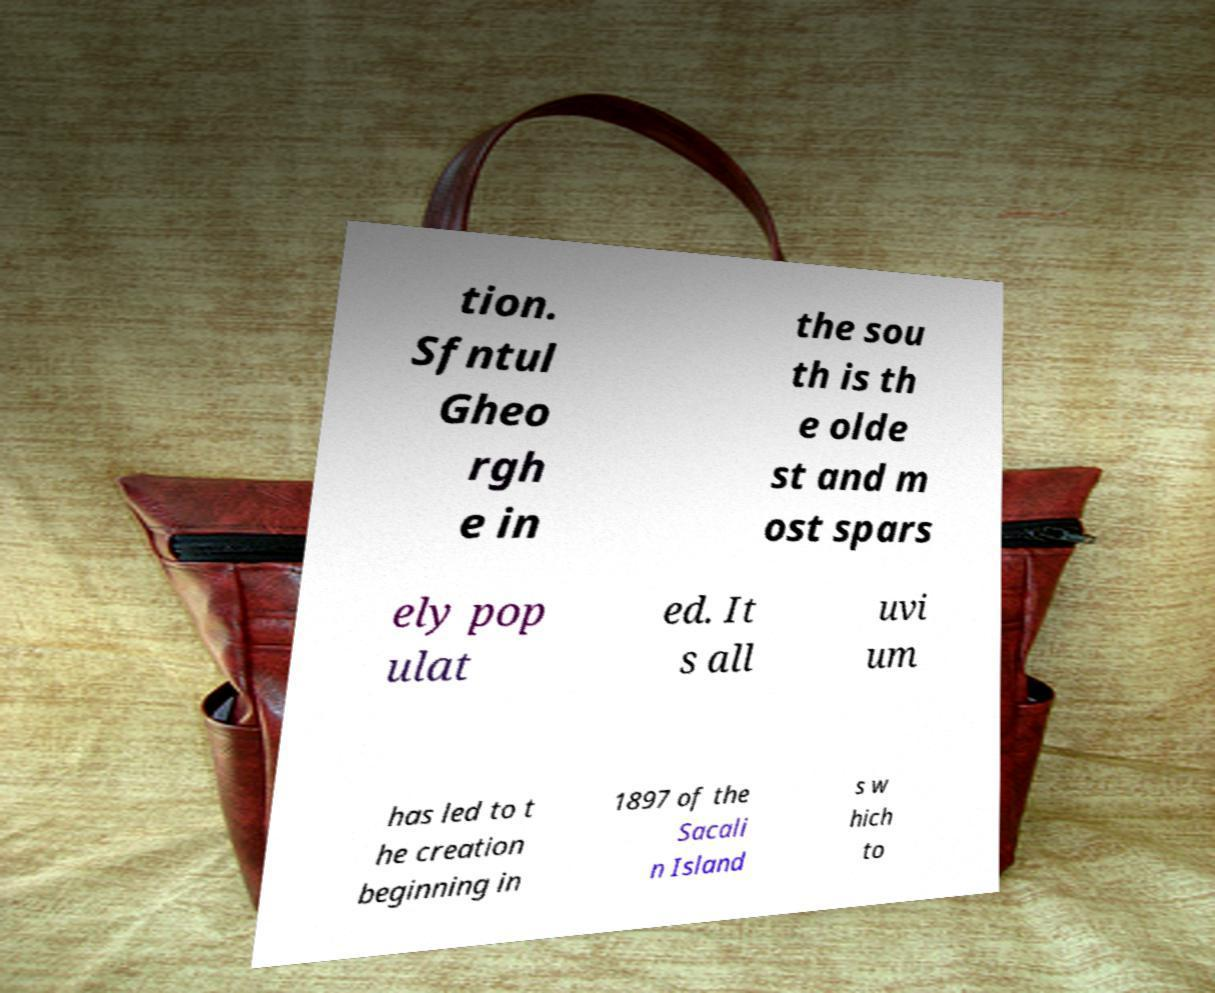I need the written content from this picture converted into text. Can you do that? tion. Sfntul Gheo rgh e in the sou th is th e olde st and m ost spars ely pop ulat ed. It s all uvi um has led to t he creation beginning in 1897 of the Sacali n Island s w hich to 